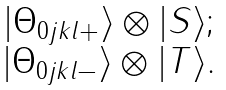<formula> <loc_0><loc_0><loc_500><loc_500>\begin{array} { c } | \Theta _ { 0 j k l + } \rangle \otimes | S \rangle ; \\ | \Theta _ { 0 j k l - } \rangle \otimes | T \rangle . \end{array}</formula> 